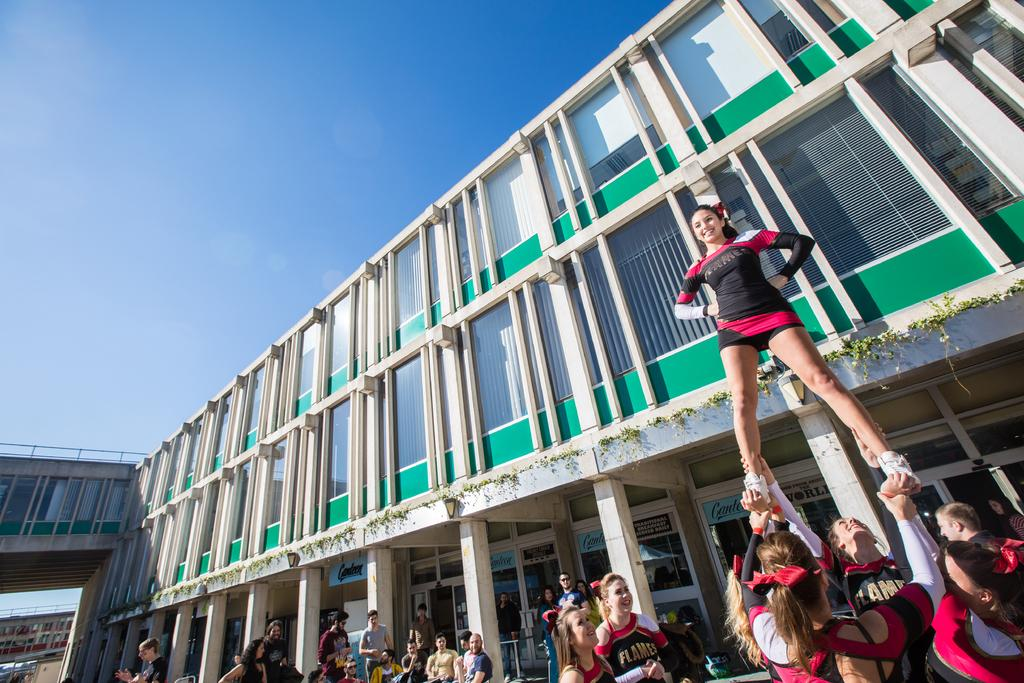What can be seen in the image? There are people standing in the image, and the women are holding legs. What type of structure is present in the image? There is a building in the image, and there are pillars visible. Can you describe the background of the image? There is a building visible in the background, and the sky is also visible. What type of condition is the screw experiencing in the image? There is no screw present in the image, so it is not possible to determine any condition related to a screw. 